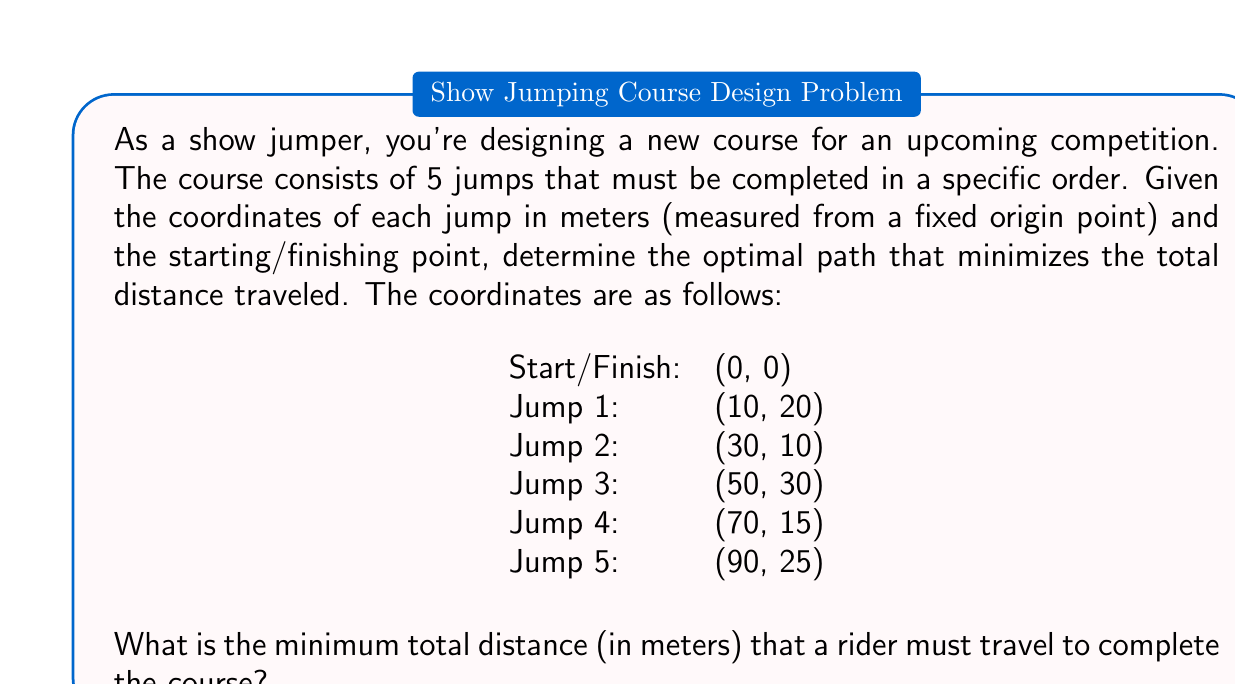What is the answer to this math problem? To solve this problem, we need to calculate the distances between consecutive points and sum them up. Since the order of the jumps is fixed, we don't need to consider different permutations.

Let's calculate the distances:

1. From Start to Jump 1:
   $$d_1 = \sqrt{(10-0)^2 + (20-0)^2} = \sqrt{100 + 400} = \sqrt{500} \approx 22.36$$

2. From Jump 1 to Jump 2:
   $$d_2 = \sqrt{(30-10)^2 + (10-20)^2} = \sqrt{400 + 100} = \sqrt{500} \approx 22.36$$

3. From Jump 2 to Jump 3:
   $$d_3 = \sqrt{(50-30)^2 + (30-10)^2} = \sqrt{400 + 400} = \sqrt{800} \approx 28.28$$

4. From Jump 3 to Jump 4:
   $$d_4 = \sqrt{(70-50)^2 + (15-30)^2} = \sqrt{400 + 225} = \sqrt{625} = 25$$

5. From Jump 4 to Jump 5:
   $$d_5 = \sqrt{(90-70)^2 + (25-15)^2} = \sqrt{400 + 100} = \sqrt{500} \approx 22.36$$

6. From Jump 5 back to Finish:
   $$d_6 = \sqrt{(0-90)^2 + (0-25)^2} = \sqrt{8100 + 625} = \sqrt{8725} \approx 93.41$$

The total distance is the sum of these individual distances:

$$d_{total} = d_1 + d_2 + d_3 + d_4 + d_5 + d_6$$

$$d_{total} \approx 22.36 + 22.36 + 28.28 + 25 + 22.36 + 93.41 = 213.77$$

Therefore, the minimum total distance a rider must travel to complete the course is approximately 213.77 meters.
Answer: The minimum total distance a rider must travel to complete the course is approximately 213.77 meters. 